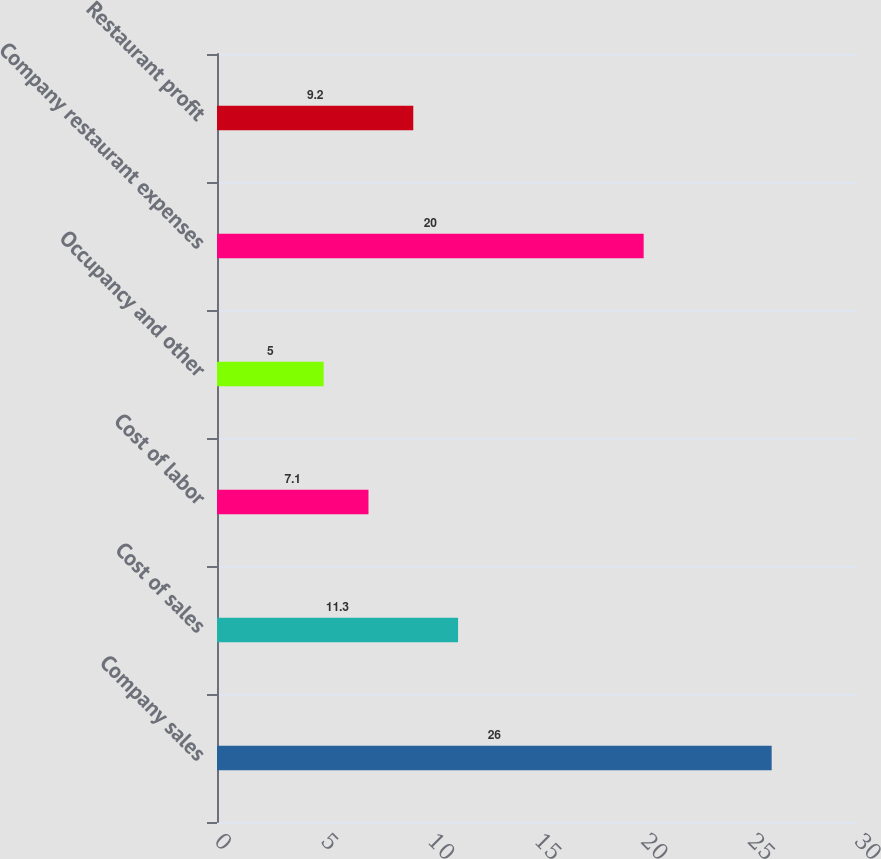<chart> <loc_0><loc_0><loc_500><loc_500><bar_chart><fcel>Company sales<fcel>Cost of sales<fcel>Cost of labor<fcel>Occupancy and other<fcel>Company restaurant expenses<fcel>Restaurant profit<nl><fcel>26<fcel>11.3<fcel>7.1<fcel>5<fcel>20<fcel>9.2<nl></chart> 